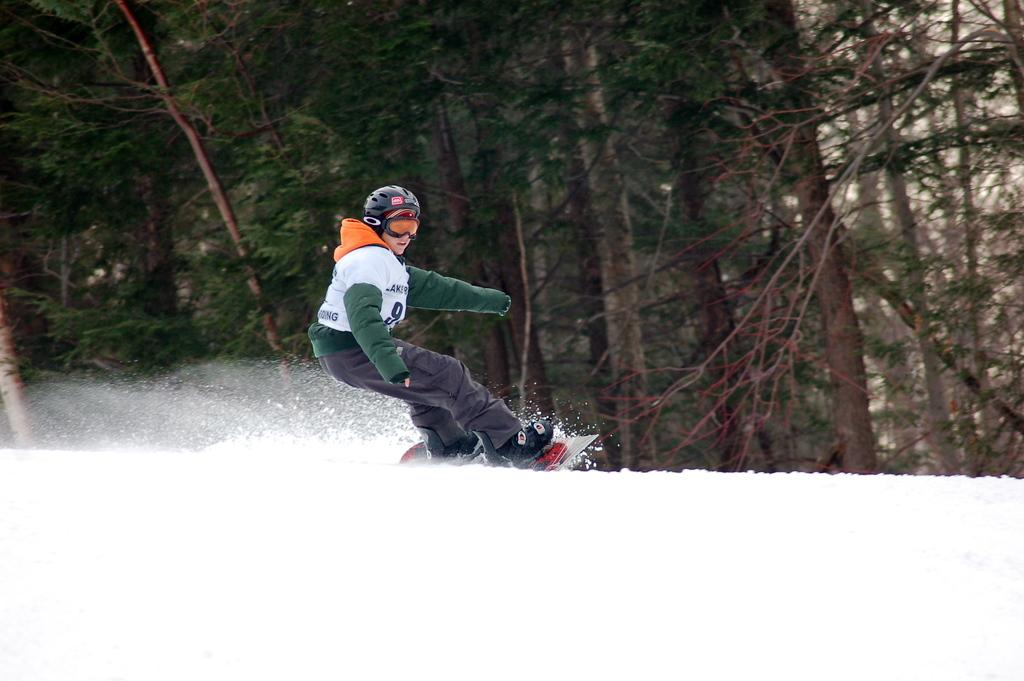What is the main subject of the image? There is a person in the image. What activity is the person engaged in? The person is skating on the ice. What can be seen in the background of the image? There are many trees visible in the background of the image. How many copies of the person's nail can be seen in the image? There are no copies of the person's nail visible in the image. What type of branch is the person holding in the image? There is no branch present in the image; the person is skating on the ice. 